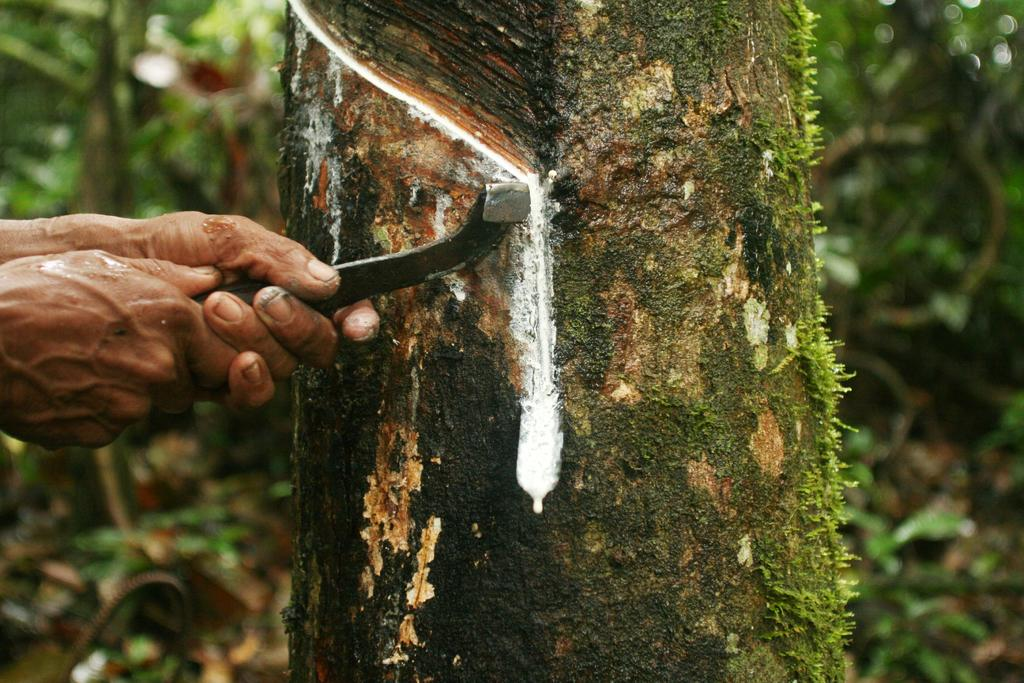What is the main subject of the image? There is a tree stem in the image. Are there any other subjects or objects in the image? Yes, there is a person in the image. What is the person doing in the image? The person's hands are holding an object. How many apples are on the pan in the image? There is no pan or apples present in the image. 